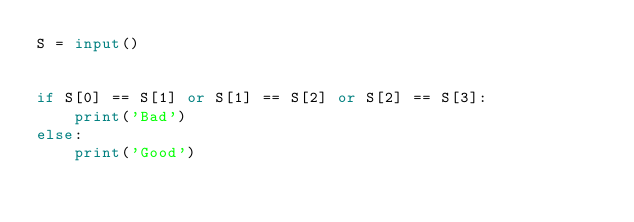Convert code to text. <code><loc_0><loc_0><loc_500><loc_500><_Python_>S = input()


if S[0] == S[1] or S[1] == S[2] or S[2] == S[3]:
    print('Bad')
else:
    print('Good')</code> 